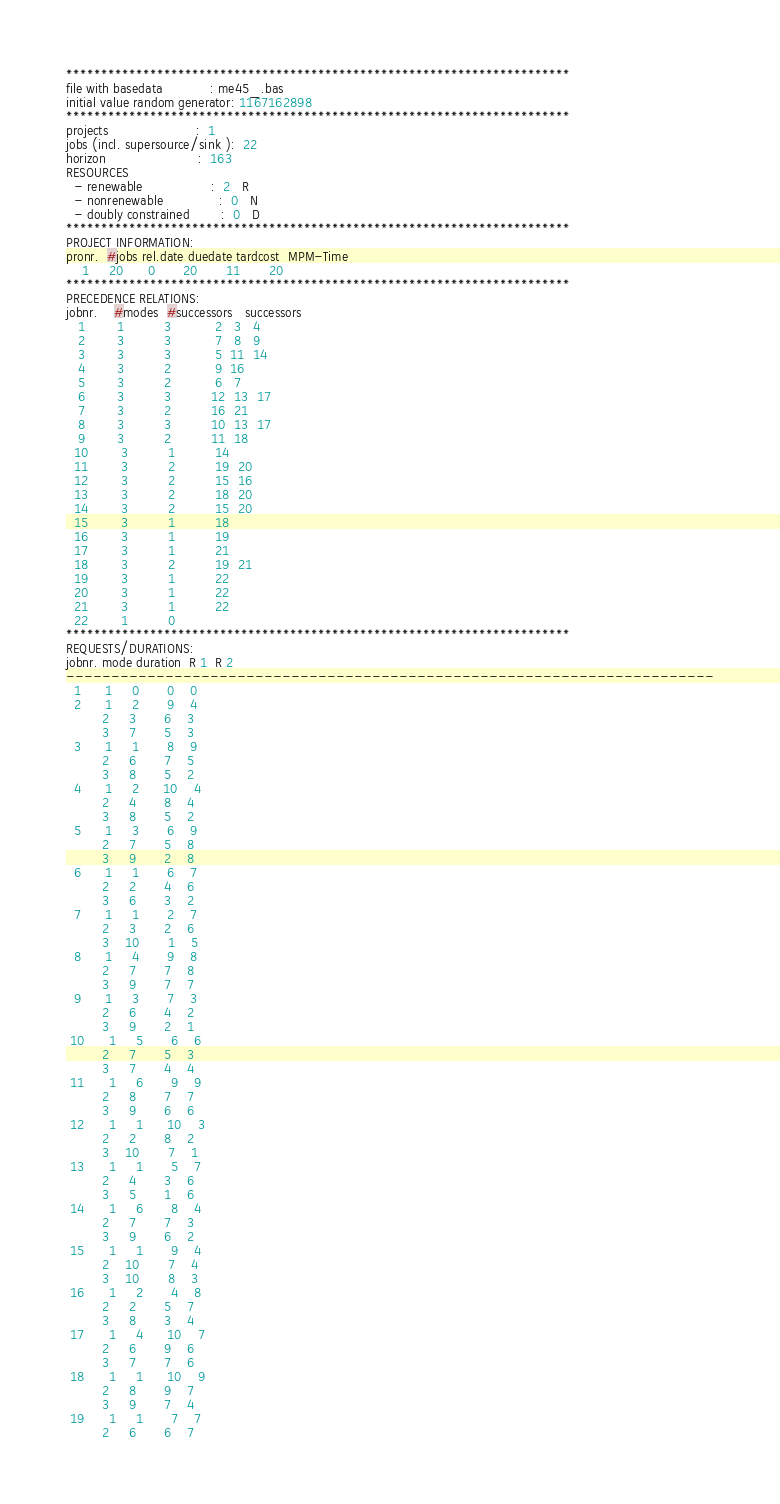Convert code to text. <code><loc_0><loc_0><loc_500><loc_500><_ObjectiveC_>************************************************************************
file with basedata            : me45_.bas
initial value random generator: 1167162898
************************************************************************
projects                      :  1
jobs (incl. supersource/sink ):  22
horizon                       :  163
RESOURCES
  - renewable                 :  2   R
  - nonrenewable              :  0   N
  - doubly constrained        :  0   D
************************************************************************
PROJECT INFORMATION:
pronr.  #jobs rel.date duedate tardcost  MPM-Time
    1     20      0       20       11       20
************************************************************************
PRECEDENCE RELATIONS:
jobnr.    #modes  #successors   successors
   1        1          3           2   3   4
   2        3          3           7   8   9
   3        3          3           5  11  14
   4        3          2           9  16
   5        3          2           6   7
   6        3          3          12  13  17
   7        3          2          16  21
   8        3          3          10  13  17
   9        3          2          11  18
  10        3          1          14
  11        3          2          19  20
  12        3          2          15  16
  13        3          2          18  20
  14        3          2          15  20
  15        3          1          18
  16        3          1          19
  17        3          1          21
  18        3          2          19  21
  19        3          1          22
  20        3          1          22
  21        3          1          22
  22        1          0        
************************************************************************
REQUESTS/DURATIONS:
jobnr. mode duration  R 1  R 2
------------------------------------------------------------------------
  1      1     0       0    0
  2      1     2       9    4
         2     3       6    3
         3     7       5    3
  3      1     1       8    9
         2     6       7    5
         3     8       5    2
  4      1     2      10    4
         2     4       8    4
         3     8       5    2
  5      1     3       6    9
         2     7       5    8
         3     9       2    8
  6      1     1       6    7
         2     2       4    6
         3     6       3    2
  7      1     1       2    7
         2     3       2    6
         3    10       1    5
  8      1     4       9    8
         2     7       7    8
         3     9       7    7
  9      1     3       7    3
         2     6       4    2
         3     9       2    1
 10      1     5       6    6
         2     7       5    3
         3     7       4    4
 11      1     6       9    9
         2     8       7    7
         3     9       6    6
 12      1     1      10    3
         2     2       8    2
         3    10       7    1
 13      1     1       5    7
         2     4       3    6
         3     5       1    6
 14      1     6       8    4
         2     7       7    3
         3     9       6    2
 15      1     1       9    4
         2    10       7    4
         3    10       8    3
 16      1     2       4    8
         2     2       5    7
         3     8       3    4
 17      1     4      10    7
         2     6       9    6
         3     7       7    6
 18      1     1      10    9
         2     8       9    7
         3     9       7    4
 19      1     1       7    7
         2     6       6    7</code> 